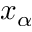Convert formula to latex. <formula><loc_0><loc_0><loc_500><loc_500>x _ { \alpha }</formula> 